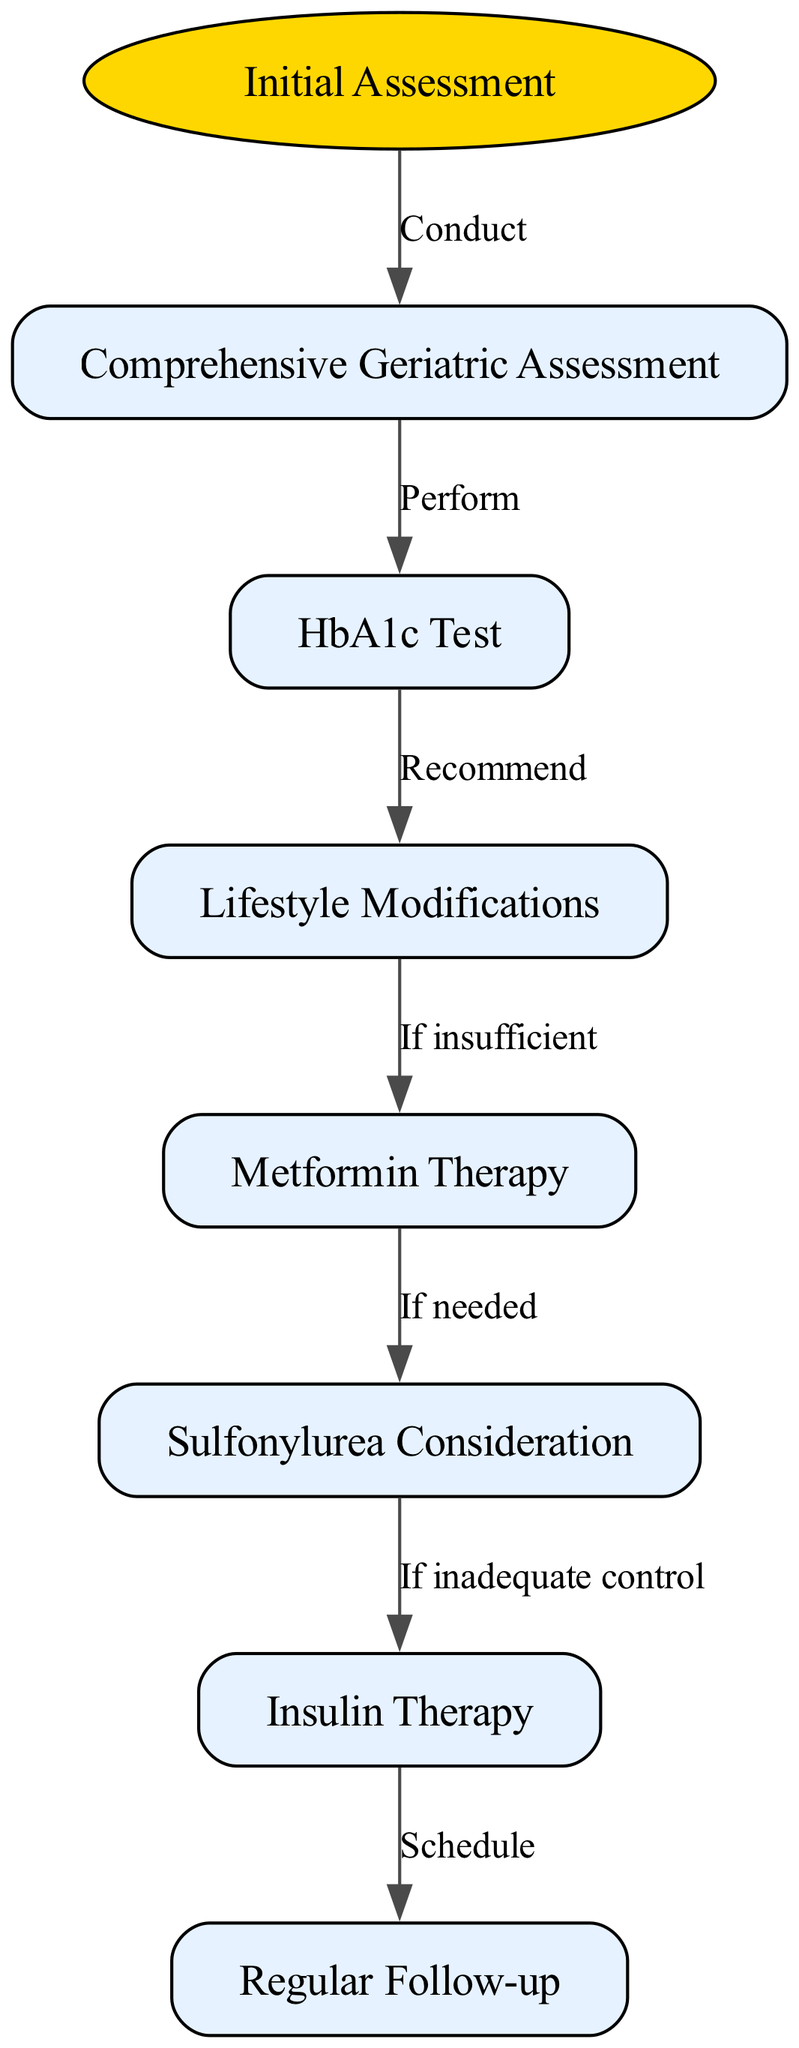What is the starting point of the clinical pathway? The diagram begins at the "Initial Assessment" node, which is indicated by the starting position in the flow of the pathway.
Answer: Initial Assessment How many nodes are present in this clinical pathway? The diagram contains a total of seven nodes, which include the start node and six additional nodes representing various steps in the process.
Answer: 7 What is the relation between "Comprehensive Geriatric Assessment" and "HbA1c Test"? The relationship is that the "HbA1c Test" is performed after conducting the "Comprehensive Geriatric Assessment," indicating a sequence in the management process.
Answer: Perform What therapy is considered if "Metformin Therapy" is not sufficient? If "Metformin Therapy" is insufficient, the next consideration is "Sulfonylurea," which reflects the escalation of treatment options in diabetes care.
Answer: Sulfonylurea Consideration What follows "Insulin Therapy" in the clinical pathway? After "Insulin Therapy," the next step is to "Schedule Regular Follow-up," which ensures continued management and monitoring of the patient's condition.
Answer: Regular Follow-up What do you do if lifestyle modifications are insufficient? If lifestyle modifications are insufficient, "Metformin Therapy" is implemented as a therapeutic intervention to help manage blood sugar levels effectively.
Answer: Metformin Therapy If a patient's control is inadequate after sulfonylurea, what is the next step? In such a case, "Insulin Therapy" is initiated if control remains inadequate after trialing sulfonylurea treatment, indicating further intervention.
Answer: Insulin Therapy Which node does "Schedule" relate to in the pathway? The "Schedule" relates to the "Regular Follow-up" node, which emphasizes the importance of ongoing care and assessment in managing diabetes.
Answer: Regular Follow-up 